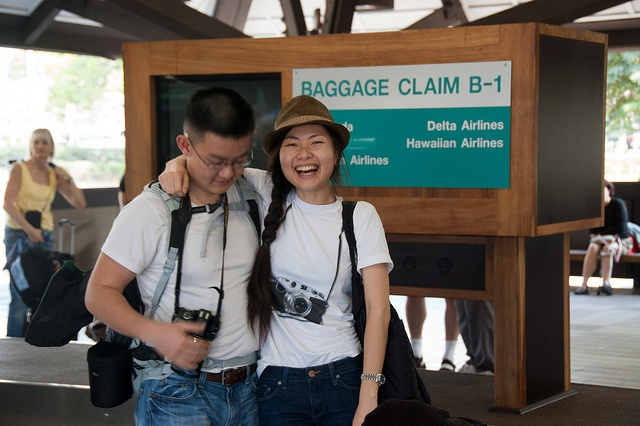Describe the objects in this image and their specific colors. I can see people in gray, black, lightgray, and darkgray tones, people in gray, darkgray, and black tones, people in gray, black, and tan tones, handbag in gray, black, lightgray, and maroon tones, and suitcase in gray, black, teal, and darkgray tones in this image. 